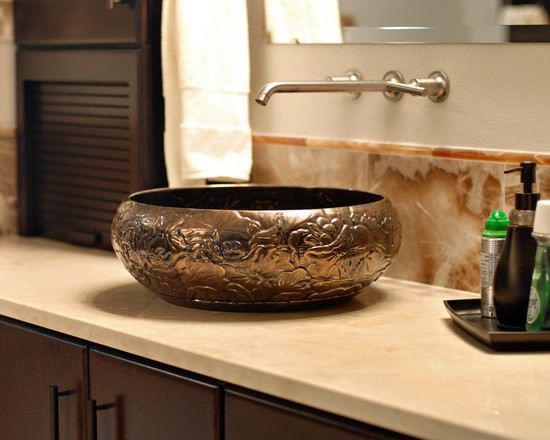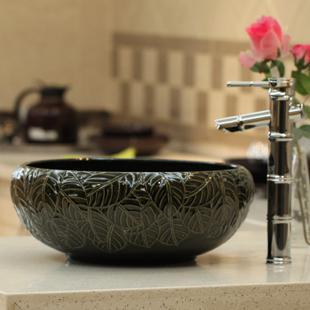The first image is the image on the left, the second image is the image on the right. Assess this claim about the two images: "There is a double vanity and a single vanity.". Correct or not? Answer yes or no. No. The first image is the image on the left, the second image is the image on the right. Evaluate the accuracy of this statement regarding the images: "There is one vase with flowers in the right image.". Is it true? Answer yes or no. Yes. 